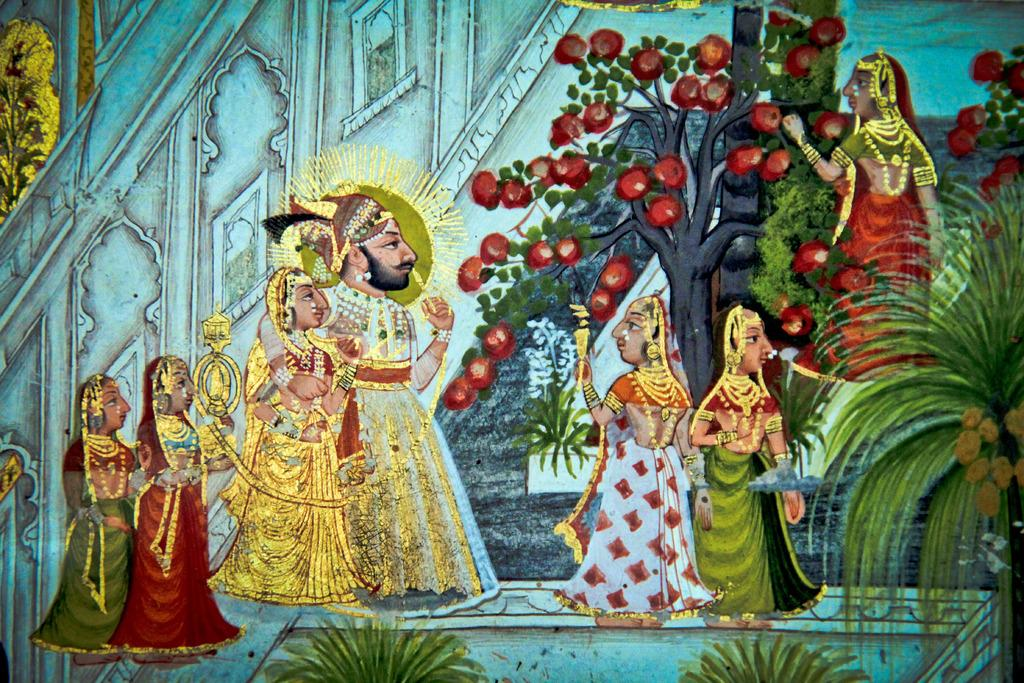What is the main subject of the image? The image contains a painting. What can be seen within the painting? There are people standing in the painting, as well as trees, a building, and a wall. Can you describe the setting of the painting? The painting features a scene with people, trees, a building, and a wall, suggesting an outdoor or urban environment. Where is the bomb hidden in the painting? There is no bomb present in the painting; it only features people, trees, a building, and a wall. 